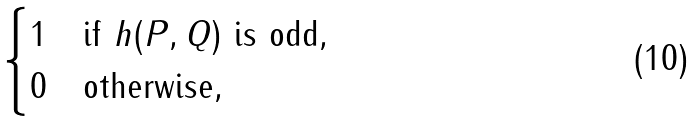Convert formula to latex. <formula><loc_0><loc_0><loc_500><loc_500>\begin{cases} 1 & \text {if $h(P,Q)$ is odd} , \\ 0 & \text {otherwise} , \end{cases}</formula> 